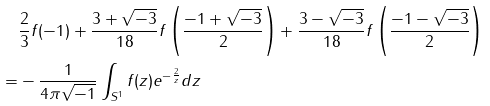<formula> <loc_0><loc_0><loc_500><loc_500>& \frac { 2 } { 3 } f ( - 1 ) + \frac { 3 + \sqrt { - 3 } } { 1 8 } f \left ( \frac { - 1 + \sqrt { - 3 } } { 2 } \right ) + \frac { 3 - \sqrt { - 3 } } { 1 8 } f \left ( \frac { - 1 - \sqrt { - 3 } } { 2 } \right ) \\ = & - \frac { 1 } { 4 \pi \sqrt { - 1 } } \int _ { S ^ { 1 } } f ( z ) e ^ { - \frac { 2 } { z } } d z</formula> 